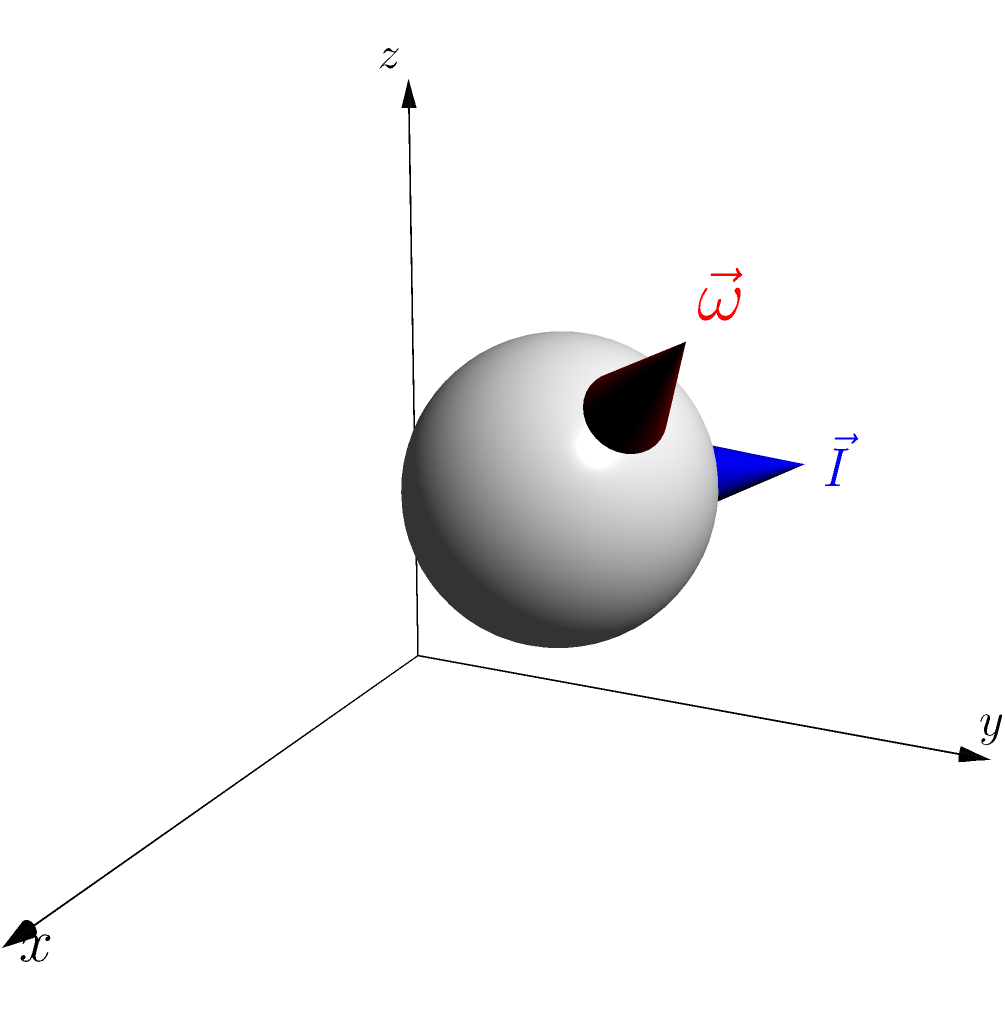A volleyball is rotating with an angular velocity vector $\vec{\omega} = (2\hat{i} + 2\hat{j} + 2\hat{k})$ rad/s. The moment of inertia vector of the volleyball is $\vec{I} = (-2\hat{i} + 2\hat{j} + 0\hat{k})$ kg·m². Calculate the net torque vector $\vec{\tau}$ acting on the volleyball. To find the net torque vector acting on the rotating volleyball, we can use the relationship between torque, moment of inertia, and angular acceleration. In this case, we'll use the equation:

$$\vec{\tau} = \vec{I} \times \vec{\omega}$$

Where:
$\vec{\tau}$ is the net torque vector
$\vec{I}$ is the moment of inertia vector
$\vec{\omega}$ is the angular velocity vector

Steps to solve:

1) We have:
   $\vec{I} = (-2\hat{i} + 2\hat{j} + 0\hat{k})$ kg·m²
   $\vec{\omega} = (2\hat{i} + 2\hat{j} + 2\hat{k})$ rad/s

2) To calculate the cross product $\vec{I} \times \vec{\omega}$, we can use the determinant method:

   $$\vec{I} \times \vec{\omega} = \begin{vmatrix}
   \hat{i} & \hat{j} & \hat{k} \\
   -2 & 2 & 0 \\
   2 & 2 & 2
   \end{vmatrix}$$

3) Expanding the determinant:
   
   $\vec{\tau} = (2 \cdot 2 - 0 \cdot 2)\hat{i} - (-2 \cdot 2 - 0 \cdot 2)\hat{j} + (-2 \cdot 2 - 2 \cdot 2)\hat{k}$

4) Simplifying:

   $\vec{\tau} = (4)\hat{i} + (4)\hat{j} + (-8)\hat{k}$ N·m

Therefore, the net torque vector acting on the volleyball is $\vec{\tau} = (4\hat{i} + 4\hat{j} - 8\hat{k})$ N·m.
Answer: $\vec{\tau} = (4\hat{i} + 4\hat{j} - 8\hat{k})$ N·m 